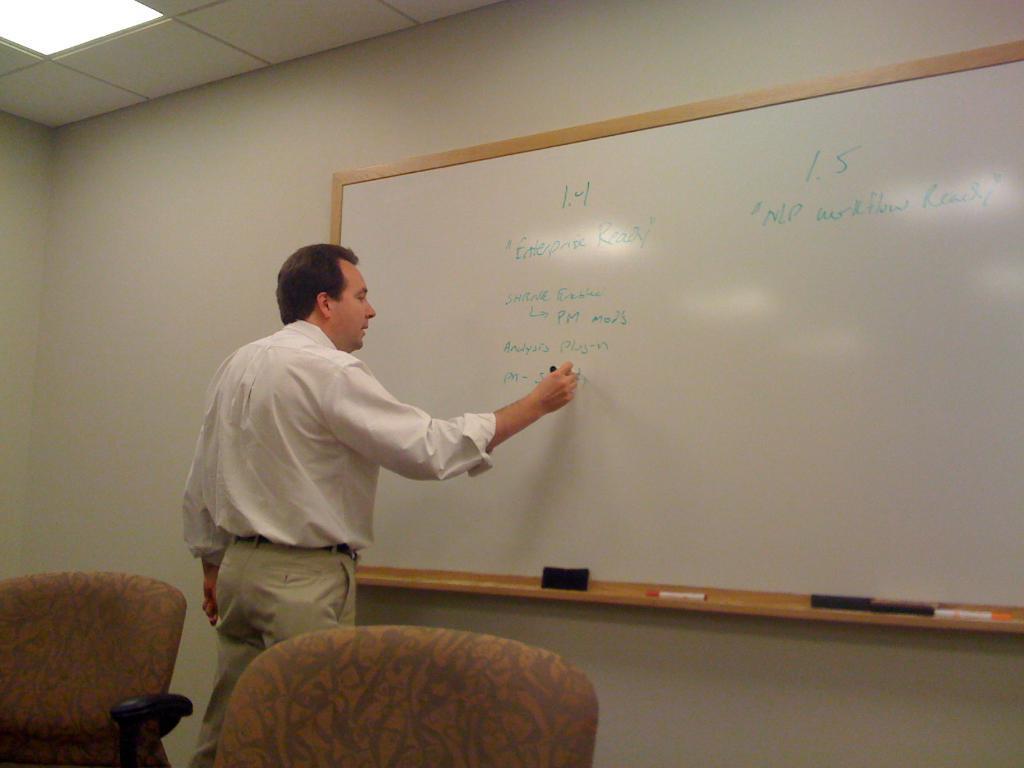Can you describe this image briefly? In this image I see a man who is wearing white shirt and I see that he is holding a marker in his hand and I see the white board on which there is something written and I see 2 markers over here and I see black color things over here and I see the wall and I see 2 chairs over here and I see the light on the ceiling. 